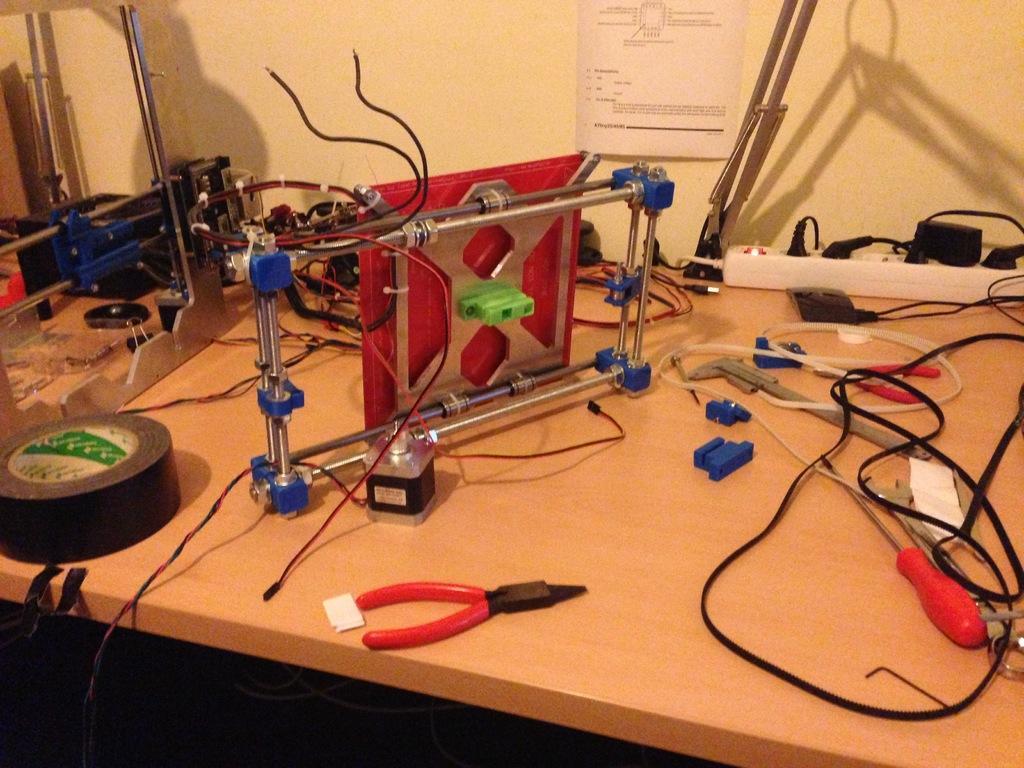Describe this image in one or two sentences. In this image we can see many tools and other objects placed on the table. There is an extension box and many plugs plugged into it. We can see a poster on the wall in the image. 